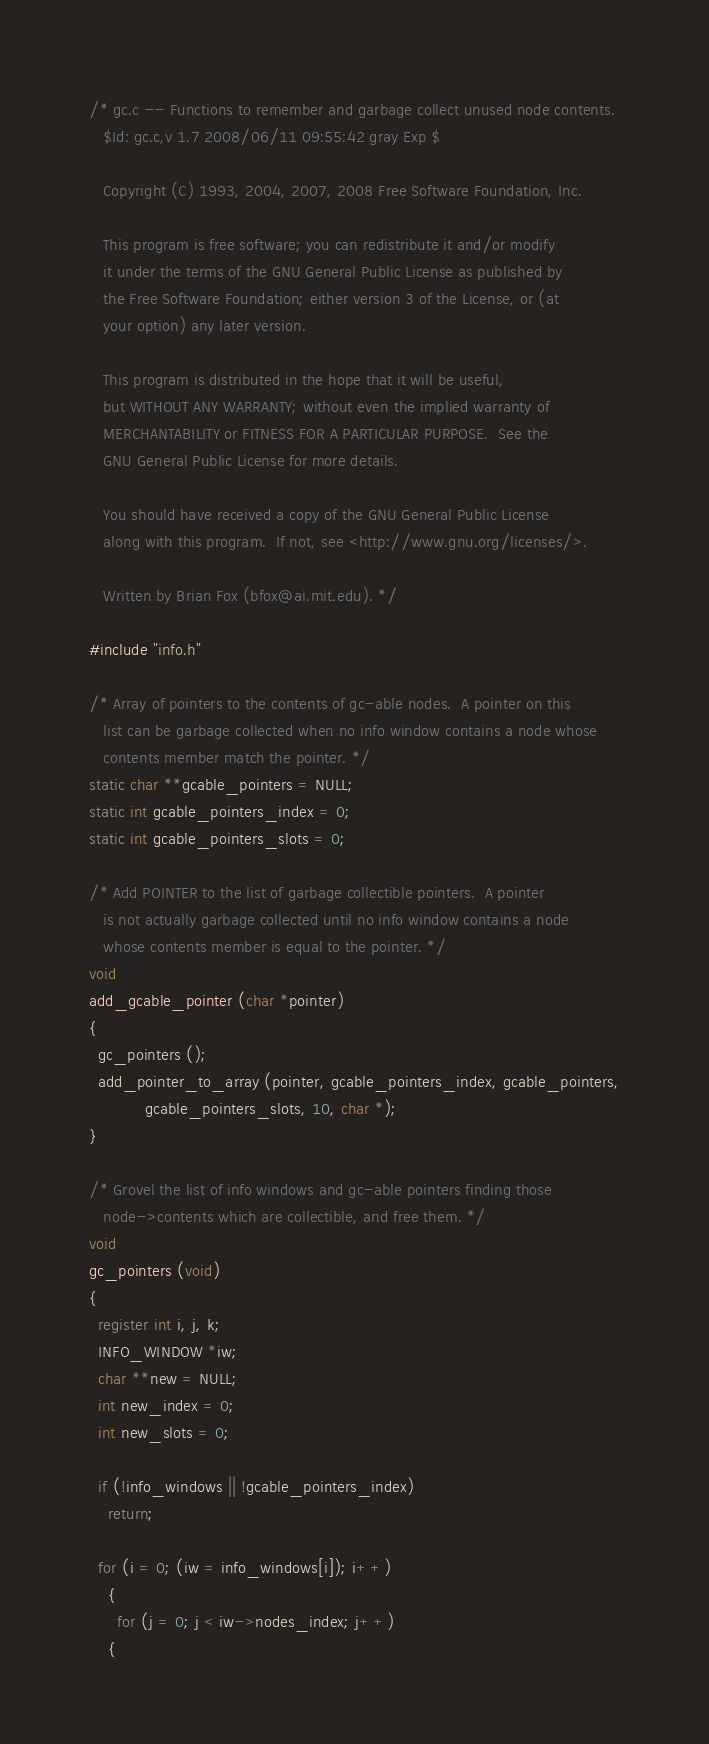<code> <loc_0><loc_0><loc_500><loc_500><_C_>/* gc.c -- Functions to remember and garbage collect unused node contents.
   $Id: gc.c,v 1.7 2008/06/11 09:55:42 gray Exp $

   Copyright (C) 1993, 2004, 2007, 2008 Free Software Foundation, Inc.

   This program is free software; you can redistribute it and/or modify
   it under the terms of the GNU General Public License as published by
   the Free Software Foundation; either version 3 of the License, or (at
   your option) any later version.

   This program is distributed in the hope that it will be useful,
   but WITHOUT ANY WARRANTY; without even the implied warranty of
   MERCHANTABILITY or FITNESS FOR A PARTICULAR PURPOSE.  See the
   GNU General Public License for more details.

   You should have received a copy of the GNU General Public License
   along with this program.  If not, see <http://www.gnu.org/licenses/>.

   Written by Brian Fox (bfox@ai.mit.edu). */

#include "info.h"

/* Array of pointers to the contents of gc-able nodes.  A pointer on this
   list can be garbage collected when no info window contains a node whose
   contents member match the pointer. */
static char **gcable_pointers = NULL;
static int gcable_pointers_index = 0;
static int gcable_pointers_slots = 0;

/* Add POINTER to the list of garbage collectible pointers.  A pointer
   is not actually garbage collected until no info window contains a node
   whose contents member is equal to the pointer. */
void
add_gcable_pointer (char *pointer)
{
  gc_pointers ();
  add_pointer_to_array (pointer, gcable_pointers_index, gcable_pointers,
			gcable_pointers_slots, 10, char *);
}

/* Grovel the list of info windows and gc-able pointers finding those
   node->contents which are collectible, and free them. */
void
gc_pointers (void)
{
  register int i, j, k;
  INFO_WINDOW *iw;
  char **new = NULL;
  int new_index = 0;
  int new_slots = 0;

  if (!info_windows || !gcable_pointers_index)
    return;

  for (i = 0; (iw = info_windows[i]); i++)
    {
      for (j = 0; j < iw->nodes_index; j++)
	{</code> 